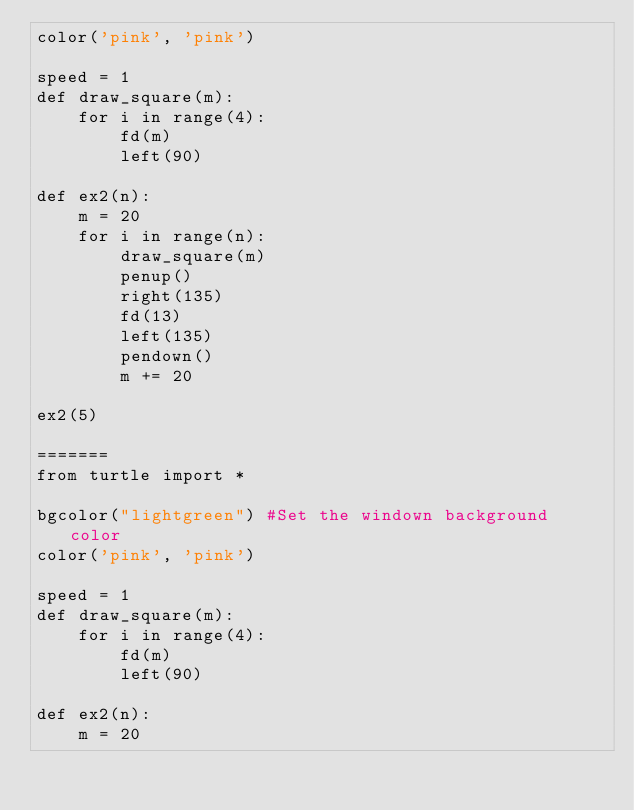<code> <loc_0><loc_0><loc_500><loc_500><_Python_>color('pink', 'pink')

speed = 1
def draw_square(m):
    for i in range(4):
        fd(m)
        left(90)

def ex2(n):
    m = 20
    for i in range(n):
        draw_square(m)
        penup()
        right(135)
        fd(13)
        left(135)
        pendown()
        m += 20
        
ex2(5)
    
=======
from turtle import *

bgcolor("lightgreen") #Set the windown background color
color('pink', 'pink')

speed = 1
def draw_square(m):
    for i in range(4):
        fd(m)
        left(90)

def ex2(n):
    m = 20</code> 